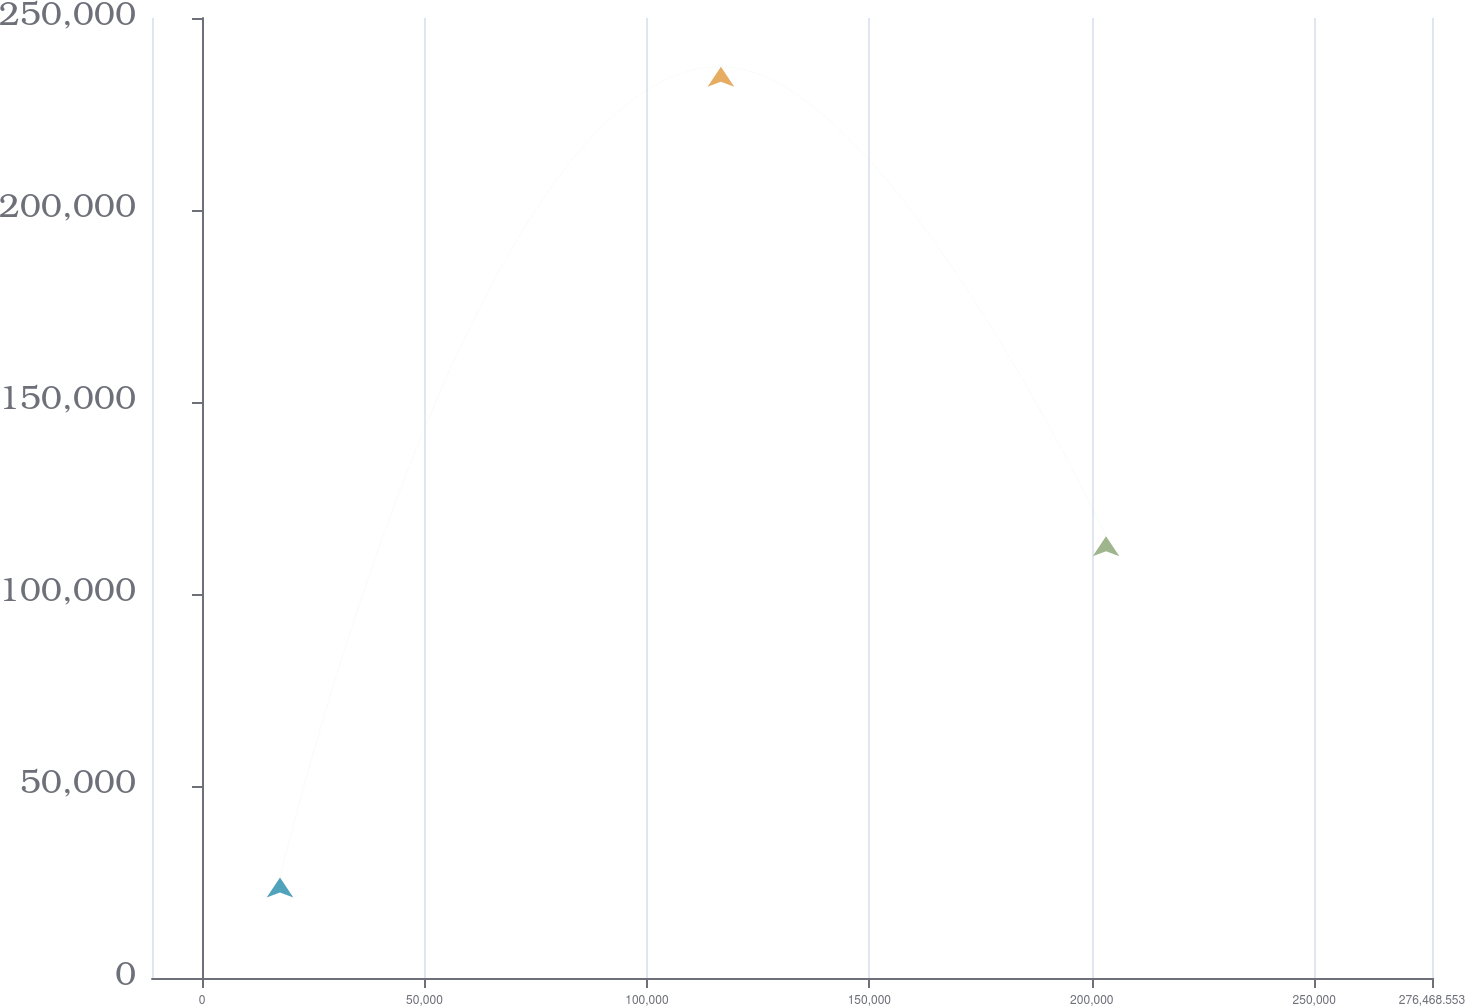<chart> <loc_0><loc_0><loc_500><loc_500><line_chart><ecel><fcel>2015<nl><fcel>17529.8<fcel>26163.1<nl><fcel>116635<fcel>237335<nl><fcel>203203<fcel>115025<nl><fcel>305240<fcel>373439<nl></chart> 